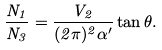Convert formula to latex. <formula><loc_0><loc_0><loc_500><loc_500>\frac { N _ { 1 } } { N _ { 3 } } = \frac { V _ { 2 } } { ( 2 \pi ) ^ { 2 } \alpha ^ { \prime } } \tan \theta .</formula> 